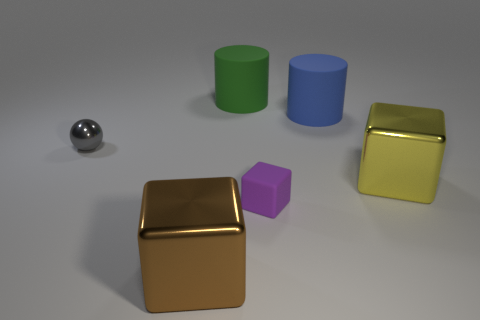The blue thing that is the same size as the brown metallic thing is what shape?
Provide a succinct answer. Cylinder. The small thing that is the same material as the large green object is what shape?
Offer a very short reply. Cube. There is a large yellow thing that is the same shape as the purple object; what is it made of?
Keep it short and to the point. Metal. There is a thing that is both to the left of the green matte thing and right of the ball; what color is it?
Keep it short and to the point. Brown. What number of other things are the same shape as the purple matte thing?
Offer a terse response. 2. What shape is the tiny shiny object?
Make the answer very short. Sphere. Are the blue thing and the tiny gray thing made of the same material?
Your response must be concise. No. Is the number of gray spheres that are in front of the large brown thing the same as the number of yellow cubes in front of the green thing?
Make the answer very short. No. Is there a small ball that is behind the big rubber cylinder in front of the large matte cylinder to the left of the large blue cylinder?
Offer a very short reply. No. Is the brown block the same size as the blue object?
Ensure brevity in your answer.  Yes. 